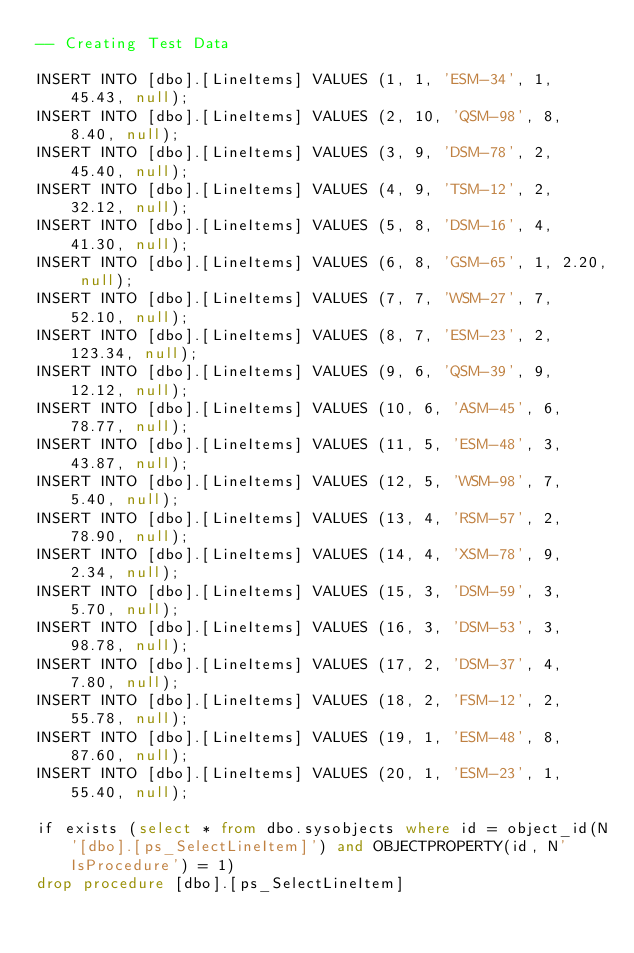Convert code to text. <code><loc_0><loc_0><loc_500><loc_500><_SQL_>-- Creating Test Data

INSERT INTO [dbo].[LineItems] VALUES (1, 1, 'ESM-34', 1, 45.43, null);
INSERT INTO [dbo].[LineItems] VALUES (2, 10, 'QSM-98', 8, 8.40, null);
INSERT INTO [dbo].[LineItems] VALUES (3, 9, 'DSM-78', 2, 45.40, null);
INSERT INTO [dbo].[LineItems] VALUES (4, 9, 'TSM-12', 2, 32.12, null);
INSERT INTO [dbo].[LineItems] VALUES (5, 8, 'DSM-16', 4, 41.30, null);
INSERT INTO [dbo].[LineItems] VALUES (6, 8, 'GSM-65', 1, 2.20, null);
INSERT INTO [dbo].[LineItems] VALUES (7, 7, 'WSM-27', 7, 52.10, null);
INSERT INTO [dbo].[LineItems] VALUES (8, 7, 'ESM-23', 2, 123.34, null);
INSERT INTO [dbo].[LineItems] VALUES (9, 6, 'QSM-39', 9, 12.12, null);
INSERT INTO [dbo].[LineItems] VALUES (10, 6, 'ASM-45', 6, 78.77, null);
INSERT INTO [dbo].[LineItems] VALUES (11, 5, 'ESM-48', 3, 43.87, null);
INSERT INTO [dbo].[LineItems] VALUES (12, 5, 'WSM-98', 7, 5.40, null);
INSERT INTO [dbo].[LineItems] VALUES (13, 4, 'RSM-57', 2, 78.90, null);
INSERT INTO [dbo].[LineItems] VALUES (14, 4, 'XSM-78', 9, 2.34, null);
INSERT INTO [dbo].[LineItems] VALUES (15, 3, 'DSM-59', 3, 5.70, null);
INSERT INTO [dbo].[LineItems] VALUES (16, 3, 'DSM-53', 3, 98.78, null);
INSERT INTO [dbo].[LineItems] VALUES (17, 2, 'DSM-37', 4, 7.80, null);
INSERT INTO [dbo].[LineItems] VALUES (18, 2, 'FSM-12', 2, 55.78, null);
INSERT INTO [dbo].[LineItems] VALUES (19, 1, 'ESM-48', 8, 87.60, null);
INSERT INTO [dbo].[LineItems] VALUES (20, 1, 'ESM-23', 1, 55.40, null);

if exists (select * from dbo.sysobjects where id = object_id(N'[dbo].[ps_SelectLineItem]') and OBJECTPROPERTY(id, N'IsProcedure') = 1)
drop procedure [dbo].[ps_SelectLineItem]

</code> 